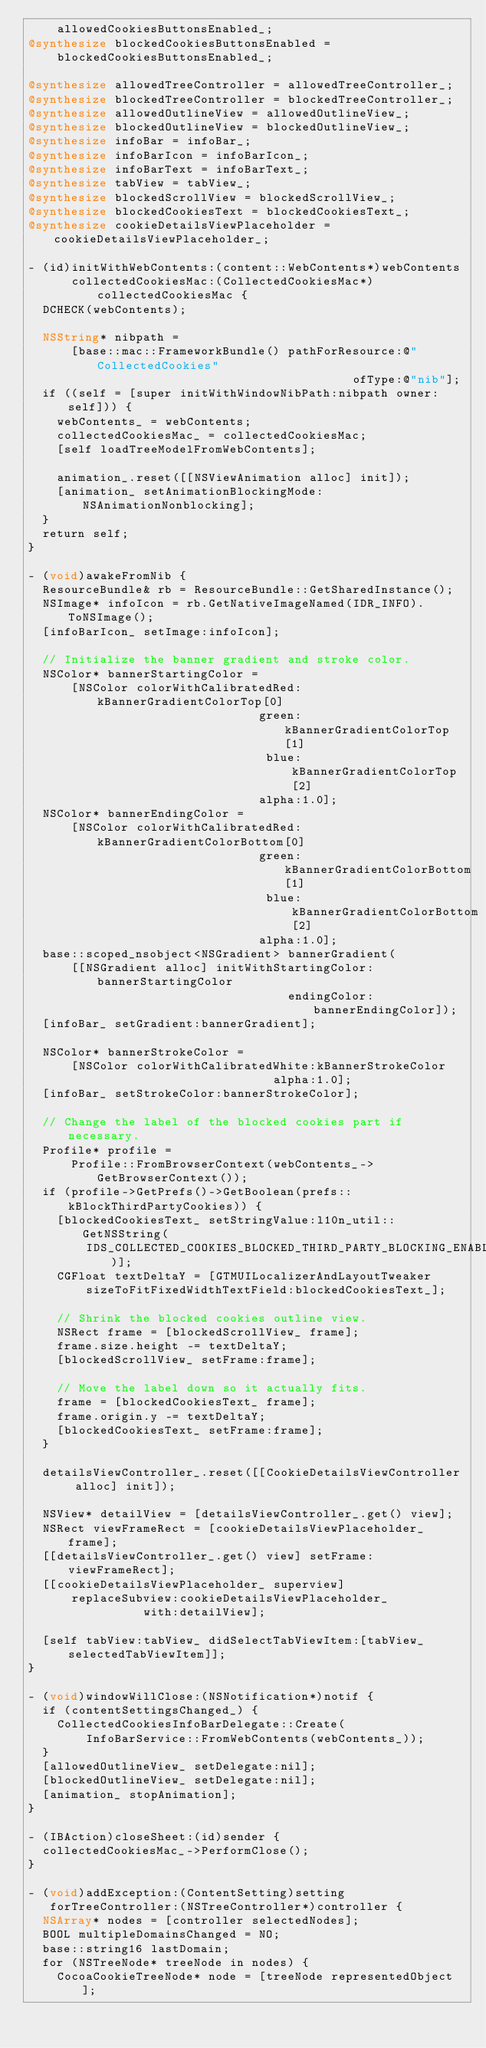<code> <loc_0><loc_0><loc_500><loc_500><_ObjectiveC_>    allowedCookiesButtonsEnabled_;
@synthesize blockedCookiesButtonsEnabled =
    blockedCookiesButtonsEnabled_;

@synthesize allowedTreeController = allowedTreeController_;
@synthesize blockedTreeController = blockedTreeController_;
@synthesize allowedOutlineView = allowedOutlineView_;
@synthesize blockedOutlineView = blockedOutlineView_;
@synthesize infoBar = infoBar_;
@synthesize infoBarIcon = infoBarIcon_;
@synthesize infoBarText = infoBarText_;
@synthesize tabView = tabView_;
@synthesize blockedScrollView = blockedScrollView_;
@synthesize blockedCookiesText = blockedCookiesText_;
@synthesize cookieDetailsViewPlaceholder = cookieDetailsViewPlaceholder_;

- (id)initWithWebContents:(content::WebContents*)webContents
      collectedCookiesMac:(CollectedCookiesMac*)collectedCookiesMac {
  DCHECK(webContents);

  NSString* nibpath =
      [base::mac::FrameworkBundle() pathForResource:@"CollectedCookies"
                                             ofType:@"nib"];
  if ((self = [super initWithWindowNibPath:nibpath owner:self])) {
    webContents_ = webContents;
    collectedCookiesMac_ = collectedCookiesMac;
    [self loadTreeModelFromWebContents];

    animation_.reset([[NSViewAnimation alloc] init]);
    [animation_ setAnimationBlockingMode:NSAnimationNonblocking];
  }
  return self;
}

- (void)awakeFromNib {
  ResourceBundle& rb = ResourceBundle::GetSharedInstance();
  NSImage* infoIcon = rb.GetNativeImageNamed(IDR_INFO).ToNSImage();
  [infoBarIcon_ setImage:infoIcon];

  // Initialize the banner gradient and stroke color.
  NSColor* bannerStartingColor =
      [NSColor colorWithCalibratedRed:kBannerGradientColorTop[0]
                                green:kBannerGradientColorTop[1]
                                 blue:kBannerGradientColorTop[2]
                                alpha:1.0];
  NSColor* bannerEndingColor =
      [NSColor colorWithCalibratedRed:kBannerGradientColorBottom[0]
                                green:kBannerGradientColorBottom[1]
                                 blue:kBannerGradientColorBottom[2]
                                alpha:1.0];
  base::scoped_nsobject<NSGradient> bannerGradient(
      [[NSGradient alloc] initWithStartingColor:bannerStartingColor
                                    endingColor:bannerEndingColor]);
  [infoBar_ setGradient:bannerGradient];

  NSColor* bannerStrokeColor =
      [NSColor colorWithCalibratedWhite:kBannerStrokeColor
                                  alpha:1.0];
  [infoBar_ setStrokeColor:bannerStrokeColor];

  // Change the label of the blocked cookies part if necessary.
  Profile* profile =
      Profile::FromBrowserContext(webContents_->GetBrowserContext());
  if (profile->GetPrefs()->GetBoolean(prefs::kBlockThirdPartyCookies)) {
    [blockedCookiesText_ setStringValue:l10n_util::GetNSString(
        IDS_COLLECTED_COOKIES_BLOCKED_THIRD_PARTY_BLOCKING_ENABLED)];
    CGFloat textDeltaY = [GTMUILocalizerAndLayoutTweaker
        sizeToFitFixedWidthTextField:blockedCookiesText_];

    // Shrink the blocked cookies outline view.
    NSRect frame = [blockedScrollView_ frame];
    frame.size.height -= textDeltaY;
    [blockedScrollView_ setFrame:frame];

    // Move the label down so it actually fits.
    frame = [blockedCookiesText_ frame];
    frame.origin.y -= textDeltaY;
    [blockedCookiesText_ setFrame:frame];
  }

  detailsViewController_.reset([[CookieDetailsViewController alloc] init]);

  NSView* detailView = [detailsViewController_.get() view];
  NSRect viewFrameRect = [cookieDetailsViewPlaceholder_ frame];
  [[detailsViewController_.get() view] setFrame:viewFrameRect];
  [[cookieDetailsViewPlaceholder_ superview]
      replaceSubview:cookieDetailsViewPlaceholder_
                with:detailView];

  [self tabView:tabView_ didSelectTabViewItem:[tabView_ selectedTabViewItem]];
}

- (void)windowWillClose:(NSNotification*)notif {
  if (contentSettingsChanged_) {
    CollectedCookiesInfoBarDelegate::Create(
        InfoBarService::FromWebContents(webContents_));
  }
  [allowedOutlineView_ setDelegate:nil];
  [blockedOutlineView_ setDelegate:nil];
  [animation_ stopAnimation];
}

- (IBAction)closeSheet:(id)sender {
  collectedCookiesMac_->PerformClose();
}

- (void)addException:(ContentSetting)setting
   forTreeController:(NSTreeController*)controller {
  NSArray* nodes = [controller selectedNodes];
  BOOL multipleDomainsChanged = NO;
  base::string16 lastDomain;
  for (NSTreeNode* treeNode in nodes) {
    CocoaCookieTreeNode* node = [treeNode representedObject];</code> 